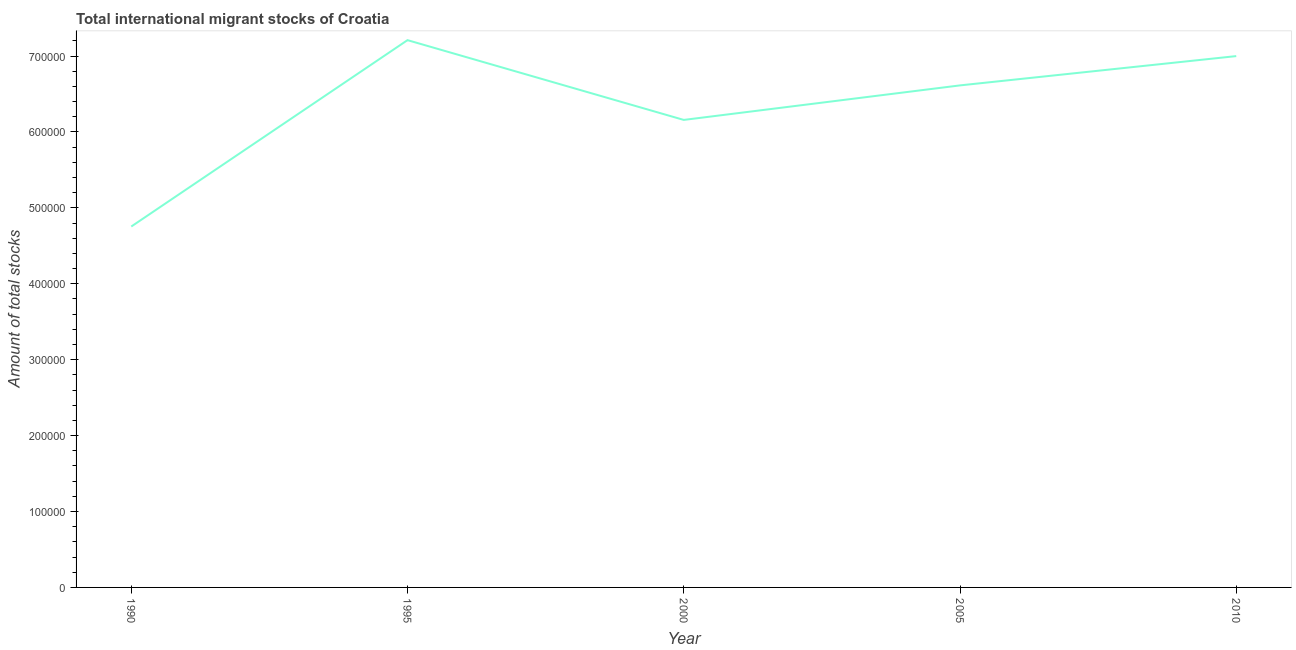What is the total number of international migrant stock in 1995?
Offer a very short reply. 7.21e+05. Across all years, what is the maximum total number of international migrant stock?
Offer a very short reply. 7.21e+05. Across all years, what is the minimum total number of international migrant stock?
Offer a terse response. 4.75e+05. In which year was the total number of international migrant stock minimum?
Your response must be concise. 1990. What is the sum of the total number of international migrant stock?
Your response must be concise. 3.17e+06. What is the difference between the total number of international migrant stock in 1990 and 2005?
Your response must be concise. -1.86e+05. What is the average total number of international migrant stock per year?
Keep it short and to the point. 6.35e+05. What is the median total number of international migrant stock?
Offer a very short reply. 6.61e+05. What is the ratio of the total number of international migrant stock in 2000 to that in 2005?
Make the answer very short. 0.93. Is the total number of international migrant stock in 1990 less than that in 2005?
Make the answer very short. Yes. Is the difference between the total number of international migrant stock in 1990 and 2000 greater than the difference between any two years?
Your answer should be very brief. No. What is the difference between the highest and the second highest total number of international migrant stock?
Provide a short and direct response. 2.10e+04. Is the sum of the total number of international migrant stock in 2000 and 2010 greater than the maximum total number of international migrant stock across all years?
Ensure brevity in your answer.  Yes. What is the difference between the highest and the lowest total number of international migrant stock?
Keep it short and to the point. 2.46e+05. In how many years, is the total number of international migrant stock greater than the average total number of international migrant stock taken over all years?
Provide a short and direct response. 3. How many years are there in the graph?
Make the answer very short. 5. What is the title of the graph?
Give a very brief answer. Total international migrant stocks of Croatia. What is the label or title of the Y-axis?
Provide a succinct answer. Amount of total stocks. What is the Amount of total stocks in 1990?
Make the answer very short. 4.75e+05. What is the Amount of total stocks in 1995?
Your response must be concise. 7.21e+05. What is the Amount of total stocks in 2000?
Offer a very short reply. 6.16e+05. What is the Amount of total stocks of 2005?
Ensure brevity in your answer.  6.61e+05. What is the Amount of total stocks of 2010?
Offer a very short reply. 7.00e+05. What is the difference between the Amount of total stocks in 1990 and 1995?
Provide a succinct answer. -2.46e+05. What is the difference between the Amount of total stocks in 1990 and 2000?
Your response must be concise. -1.40e+05. What is the difference between the Amount of total stocks in 1990 and 2005?
Offer a terse response. -1.86e+05. What is the difference between the Amount of total stocks in 1990 and 2010?
Give a very brief answer. -2.25e+05. What is the difference between the Amount of total stocks in 1995 and 2000?
Make the answer very short. 1.05e+05. What is the difference between the Amount of total stocks in 1995 and 2005?
Provide a short and direct response. 5.96e+04. What is the difference between the Amount of total stocks in 1995 and 2010?
Provide a short and direct response. 2.10e+04. What is the difference between the Amount of total stocks in 2000 and 2005?
Ensure brevity in your answer.  -4.55e+04. What is the difference between the Amount of total stocks in 2000 and 2010?
Your response must be concise. -8.41e+04. What is the difference between the Amount of total stocks in 2005 and 2010?
Keep it short and to the point. -3.86e+04. What is the ratio of the Amount of total stocks in 1990 to that in 1995?
Your answer should be very brief. 0.66. What is the ratio of the Amount of total stocks in 1990 to that in 2000?
Your answer should be very brief. 0.77. What is the ratio of the Amount of total stocks in 1990 to that in 2005?
Make the answer very short. 0.72. What is the ratio of the Amount of total stocks in 1990 to that in 2010?
Keep it short and to the point. 0.68. What is the ratio of the Amount of total stocks in 1995 to that in 2000?
Your answer should be very brief. 1.17. What is the ratio of the Amount of total stocks in 1995 to that in 2005?
Offer a terse response. 1.09. What is the ratio of the Amount of total stocks in 1995 to that in 2010?
Your response must be concise. 1.03. What is the ratio of the Amount of total stocks in 2005 to that in 2010?
Ensure brevity in your answer.  0.94. 